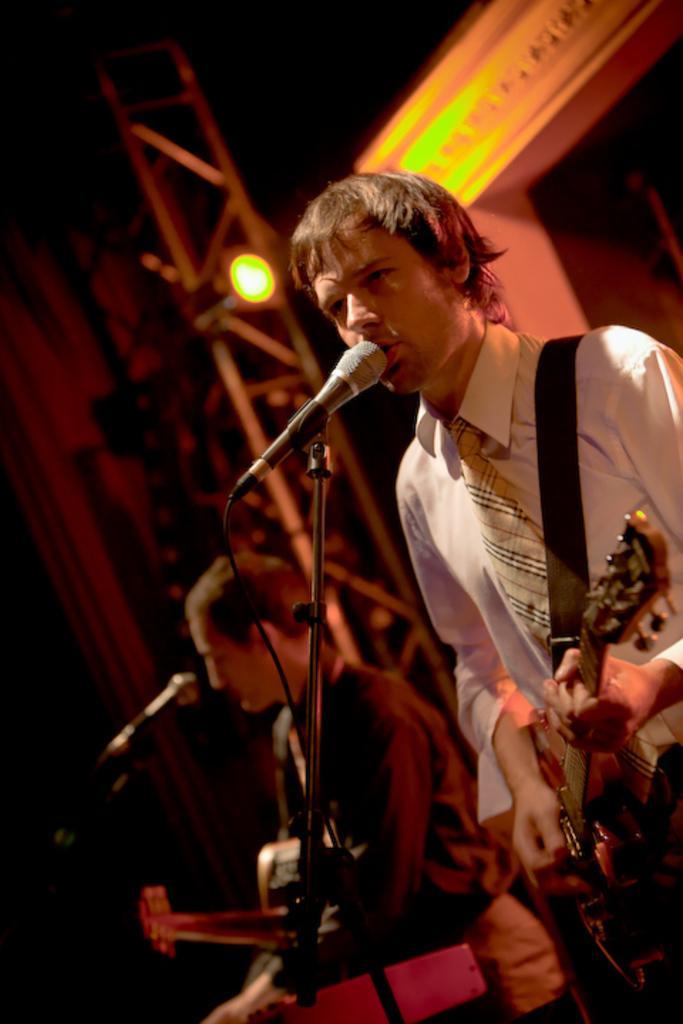Please provide a concise description of this image. In the image we can see there are two people wearing clothes and they are holding musical instruments in their hands. Here we can see microphones and cable wires. Here we can see the light and the background is slightly blurred. 